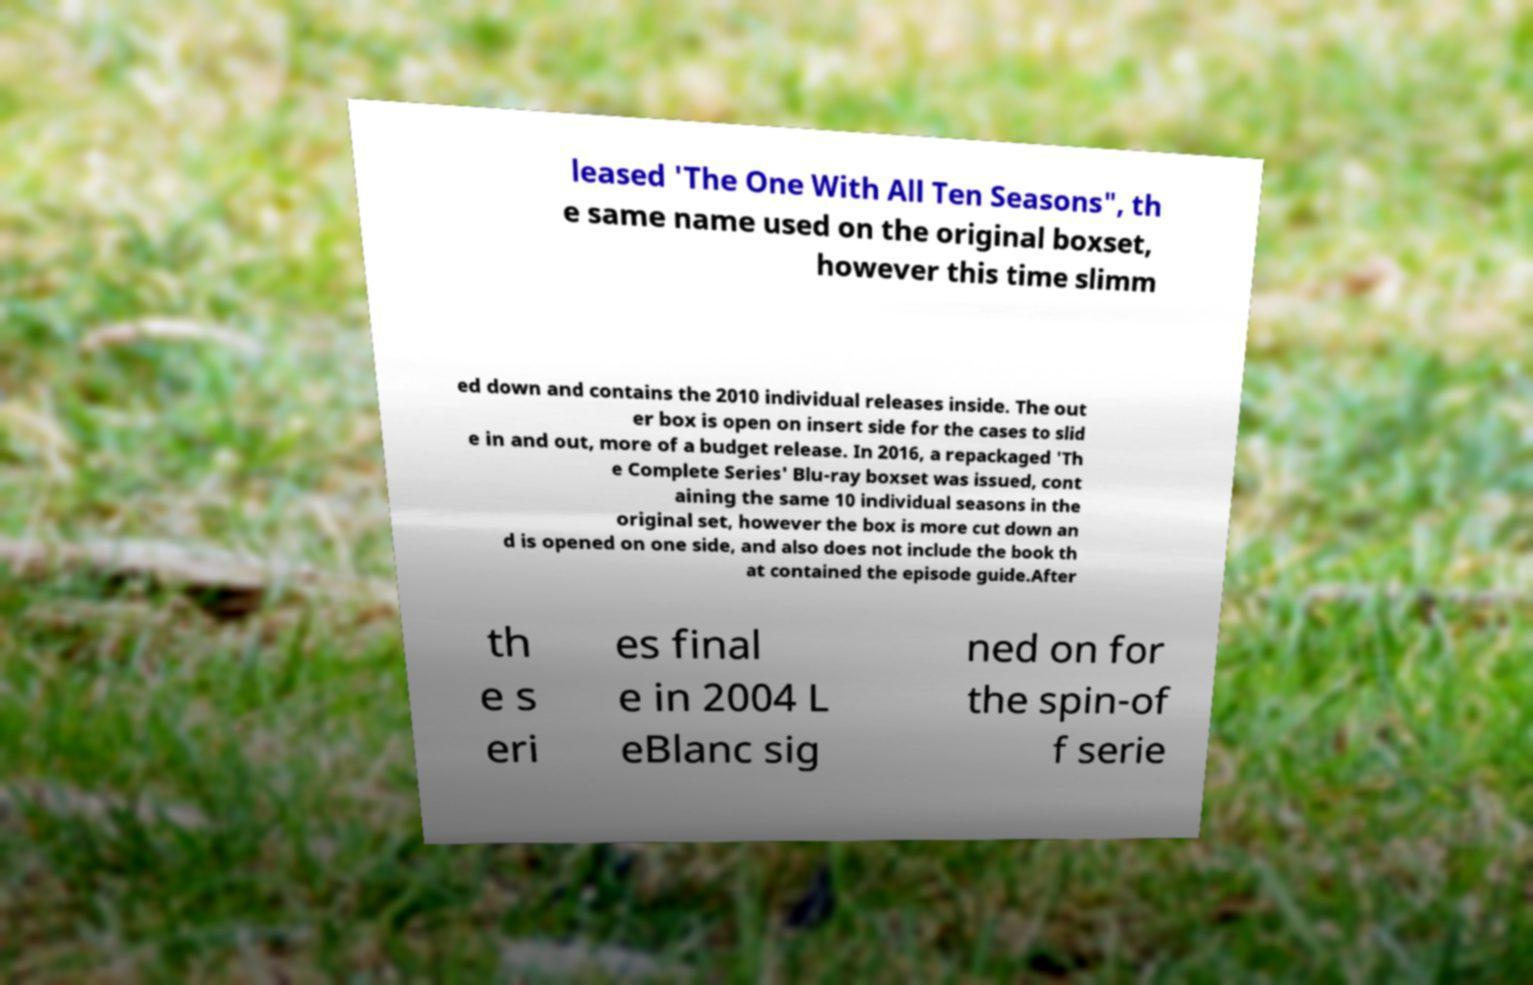What messages or text are displayed in this image? I need them in a readable, typed format. leased 'The One With All Ten Seasons", th e same name used on the original boxset, however this time slimm ed down and contains the 2010 individual releases inside. The out er box is open on insert side for the cases to slid e in and out, more of a budget release. In 2016, a repackaged 'Th e Complete Series' Blu-ray boxset was issued, cont aining the same 10 individual seasons in the original set, however the box is more cut down an d is opened on one side, and also does not include the book th at contained the episode guide.After th e s eri es final e in 2004 L eBlanc sig ned on for the spin-of f serie 